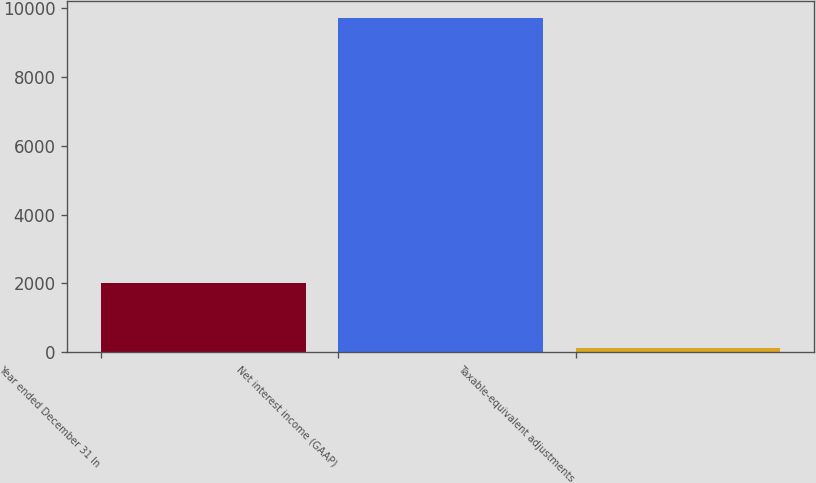<chart> <loc_0><loc_0><loc_500><loc_500><bar_chart><fcel>Year ended December 31 In<fcel>Net interest income (GAAP)<fcel>Taxable-equivalent adjustments<nl><fcel>2018<fcel>9721<fcel>115<nl></chart> 